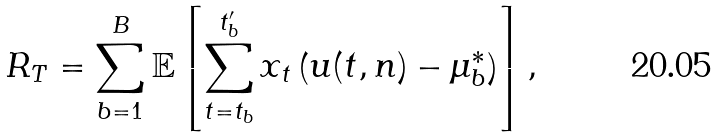Convert formula to latex. <formula><loc_0><loc_0><loc_500><loc_500>R _ { T } = \sum _ { b = 1 } ^ { B } \mathbb { E } \left [ \sum _ { t = t _ { b } } ^ { t ^ { \prime } _ { b } } x _ { t } \left ( u ( t , n ) - \mu _ { b } ^ { * } \right ) \right ] ,</formula> 